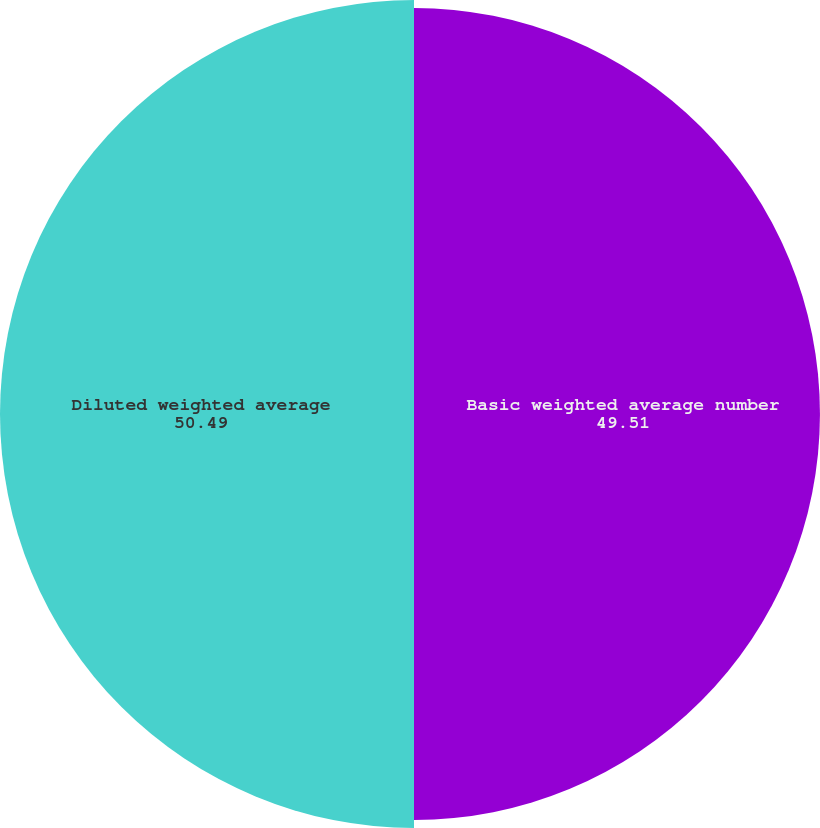Convert chart to OTSL. <chart><loc_0><loc_0><loc_500><loc_500><pie_chart><fcel>Basic weighted average number<fcel>Diluted weighted average<nl><fcel>49.51%<fcel>50.49%<nl></chart> 